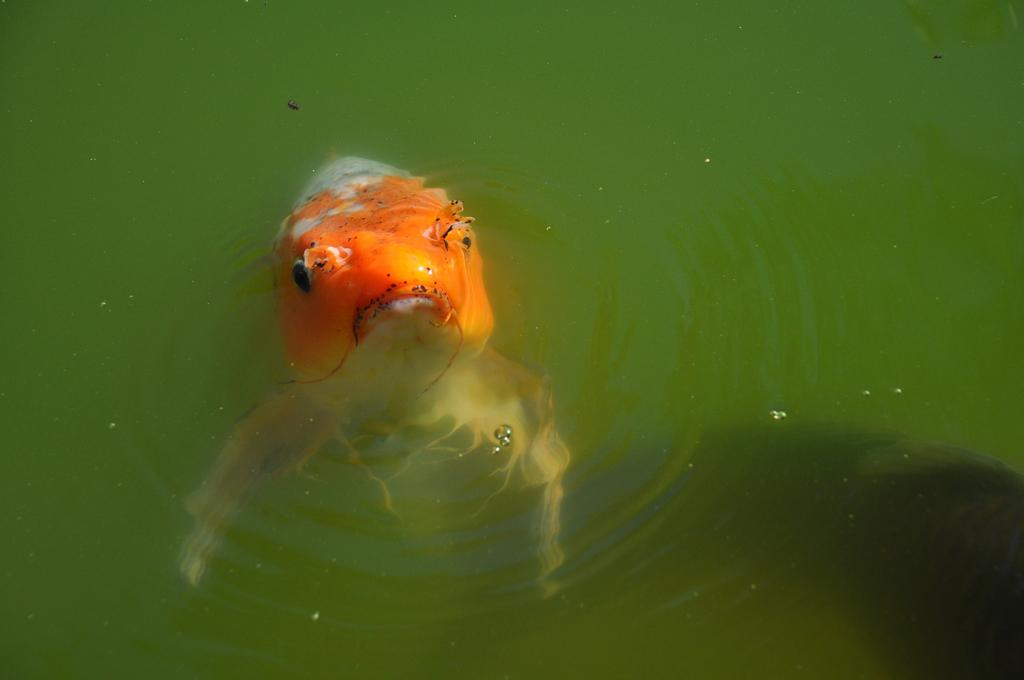What type of animal is in the image? There is a fish in the image. Where is the fish located? The fish is in the water. Can you see a nest for the kittens in the image? There are no kittens or nests present in the image; it features a fish in the water. 